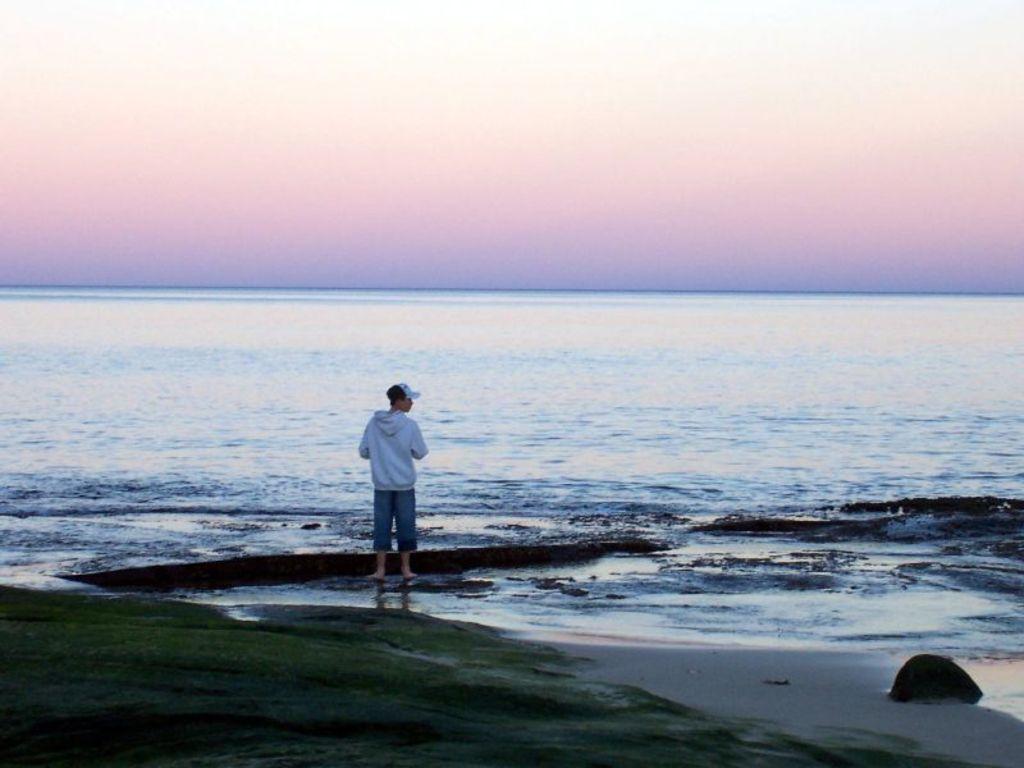How would you summarize this image in a sentence or two? In the picture there is a man standing in front of the sea. 